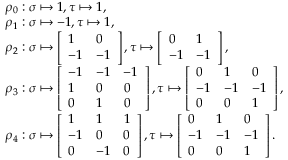<formula> <loc_0><loc_0><loc_500><loc_500>\begin{array} { r l } & { \rho _ { 0 } \colon \sigma \mapsto 1 , \tau \mapsto 1 , } \\ & { \rho _ { 1 } \colon \sigma \mapsto - 1 , \tau \mapsto 1 , } \\ & { \rho _ { 2 } \colon \sigma \mapsto \left [ \begin{array} { l l } { 1 } & { 0 } \\ { - 1 } & { - 1 } \end{array} \right ] , \tau \mapsto \left [ \begin{array} { l l } { 0 } & { 1 } \\ { - 1 } & { - 1 } \end{array} \right ] , } \\ & { \rho _ { 3 } \colon \sigma \mapsto \left [ \begin{array} { l l l } { - 1 } & { - 1 } & { - 1 } \\ { 1 } & { 0 } & { 0 } \\ { 0 } & { 1 } & { 0 } \end{array} \right ] , \tau \mapsto \left [ \begin{array} { l l l } { 0 } & { 1 } & { 0 } \\ { - 1 } & { - 1 } & { - 1 } \\ { 0 } & { 0 } & { 1 } \end{array} \right ] , } \\ & { \rho _ { 4 } \colon \sigma \mapsto \left [ \begin{array} { l l l } { 1 } & { 1 } & { 1 } \\ { - 1 } & { 0 } & { 0 } \\ { 0 } & { - 1 } & { 0 } \end{array} \right ] , \tau \mapsto \left [ \begin{array} { l l l } { 0 } & { 1 } & { 0 } \\ { - 1 } & { - 1 } & { - 1 } \\ { 0 } & { 0 } & { 1 } \end{array} \right ] . } \end{array}</formula> 